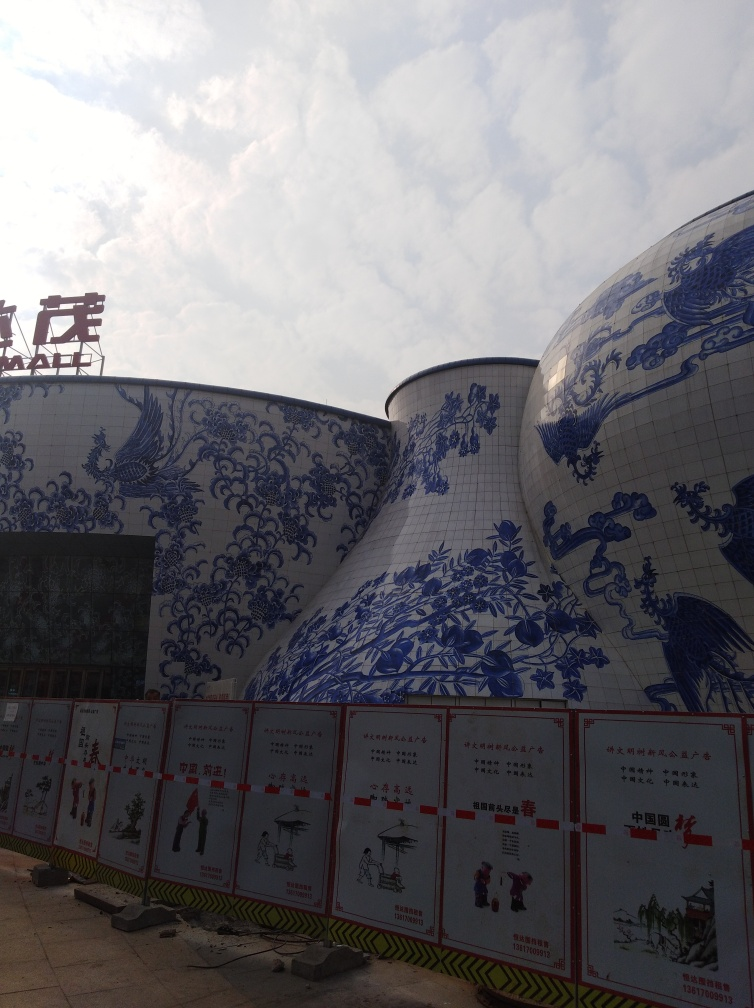What kind of buildings are these, and what is their function? The structures in the image are quite unique and appear to be adorned with blue and white porcelain designs. These buildings are likely to be part of a cultural or historical exhibition, possibly a museum or similar institution, given their decorative exteriors and prominent display. Can you tell me more about the design on the buildings? Certainly! The designs feature traditional Chinese blue and white porcelain patterns, which are known for depicting historical scenes, dragon motifs, and floral arrangements. Such artistic designs are symbols of cultural heritage and might reflect the thematic focus of the institution these buildings belong to. 